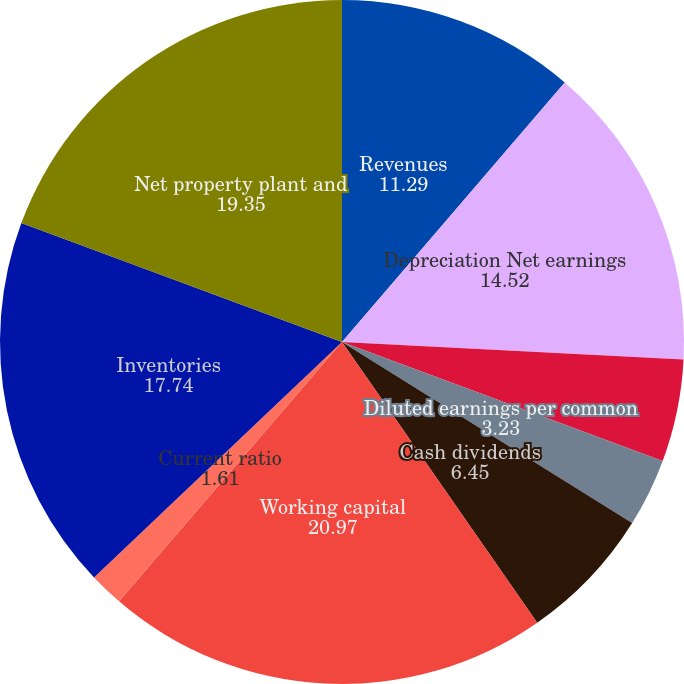<chart> <loc_0><loc_0><loc_500><loc_500><pie_chart><fcel>Revenues<fcel>Depreciation Net earnings<fcel>Basic earnings per common<fcel>Diluted earnings per common<fcel>Cash dividends<fcel>Per common share<fcel>Working capital<fcel>Current ratio<fcel>Inventories<fcel>Net property plant and<nl><fcel>11.29%<fcel>14.52%<fcel>4.84%<fcel>3.23%<fcel>6.45%<fcel>0.0%<fcel>20.97%<fcel>1.61%<fcel>17.74%<fcel>19.35%<nl></chart> 